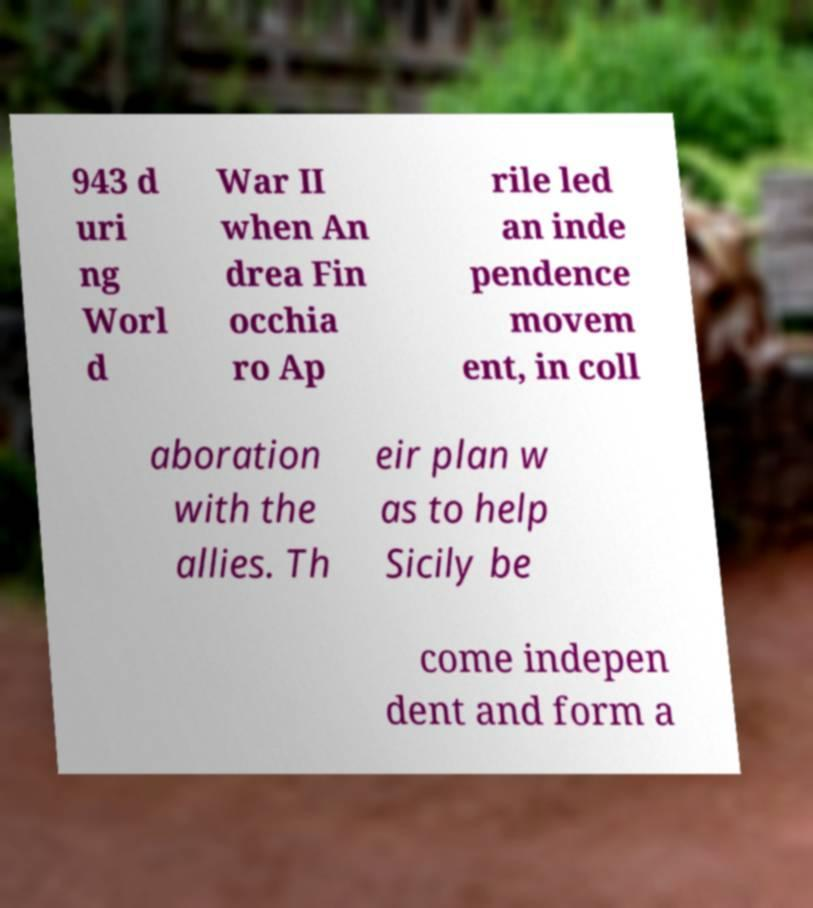Could you extract and type out the text from this image? 943 d uri ng Worl d War II when An drea Fin occhia ro Ap rile led an inde pendence movem ent, in coll aboration with the allies. Th eir plan w as to help Sicily be come indepen dent and form a 